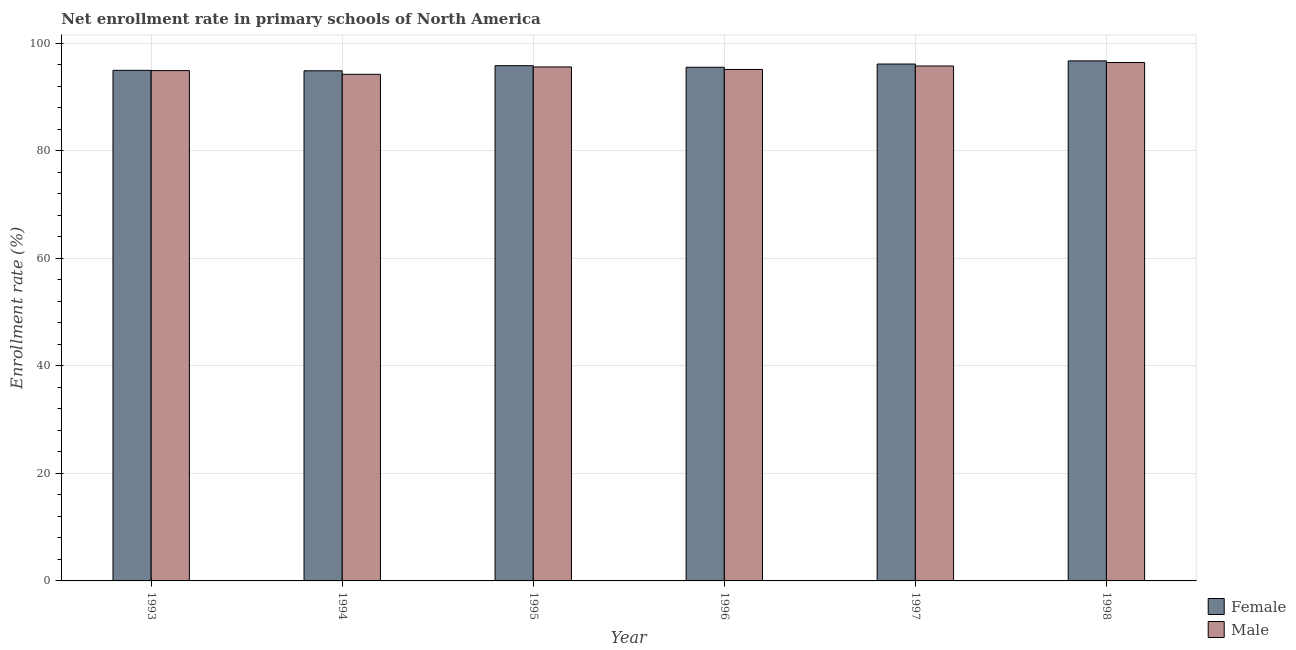Are the number of bars per tick equal to the number of legend labels?
Keep it short and to the point. Yes. How many bars are there on the 1st tick from the left?
Your answer should be compact. 2. What is the enrollment rate of female students in 1997?
Keep it short and to the point. 96.17. Across all years, what is the maximum enrollment rate of female students?
Your answer should be compact. 96.76. Across all years, what is the minimum enrollment rate of male students?
Offer a very short reply. 94.26. In which year was the enrollment rate of female students minimum?
Give a very brief answer. 1994. What is the total enrollment rate of female students in the graph?
Your answer should be very brief. 574.28. What is the difference between the enrollment rate of male students in 1995 and that in 1997?
Offer a very short reply. -0.18. What is the difference between the enrollment rate of female students in 1997 and the enrollment rate of male students in 1996?
Offer a terse response. 0.6. What is the average enrollment rate of male students per year?
Offer a terse response. 95.38. In how many years, is the enrollment rate of female students greater than 60 %?
Offer a terse response. 6. What is the ratio of the enrollment rate of male students in 1995 to that in 1998?
Provide a short and direct response. 0.99. Is the difference between the enrollment rate of male students in 1993 and 1997 greater than the difference between the enrollment rate of female students in 1993 and 1997?
Your response must be concise. No. What is the difference between the highest and the second highest enrollment rate of female students?
Offer a terse response. 0.58. What is the difference between the highest and the lowest enrollment rate of male students?
Your answer should be compact. 2.19. What does the 2nd bar from the left in 1997 represents?
Your answer should be compact. Male. What does the 1st bar from the right in 1995 represents?
Your response must be concise. Male. Are all the bars in the graph horizontal?
Make the answer very short. No. How many years are there in the graph?
Your answer should be compact. 6. What is the difference between two consecutive major ticks on the Y-axis?
Offer a very short reply. 20. Does the graph contain any zero values?
Your answer should be compact. No. What is the title of the graph?
Make the answer very short. Net enrollment rate in primary schools of North America. What is the label or title of the X-axis?
Ensure brevity in your answer.  Year. What is the label or title of the Y-axis?
Your response must be concise. Enrollment rate (%). What is the Enrollment rate (%) of Female in 1993?
Your answer should be very brief. 95. What is the Enrollment rate (%) in Male in 1993?
Your response must be concise. 94.95. What is the Enrollment rate (%) of Female in 1994?
Give a very brief answer. 94.91. What is the Enrollment rate (%) of Male in 1994?
Your answer should be very brief. 94.26. What is the Enrollment rate (%) of Female in 1995?
Offer a terse response. 95.87. What is the Enrollment rate (%) of Male in 1995?
Your response must be concise. 95.63. What is the Enrollment rate (%) of Female in 1996?
Make the answer very short. 95.57. What is the Enrollment rate (%) in Male in 1996?
Your answer should be very brief. 95.16. What is the Enrollment rate (%) in Female in 1997?
Ensure brevity in your answer.  96.17. What is the Enrollment rate (%) in Male in 1997?
Offer a very short reply. 95.81. What is the Enrollment rate (%) of Female in 1998?
Offer a very short reply. 96.76. What is the Enrollment rate (%) of Male in 1998?
Provide a succinct answer. 96.45. Across all years, what is the maximum Enrollment rate (%) in Female?
Give a very brief answer. 96.76. Across all years, what is the maximum Enrollment rate (%) of Male?
Your answer should be very brief. 96.45. Across all years, what is the minimum Enrollment rate (%) in Female?
Ensure brevity in your answer.  94.91. Across all years, what is the minimum Enrollment rate (%) in Male?
Your answer should be compact. 94.26. What is the total Enrollment rate (%) in Female in the graph?
Offer a terse response. 574.28. What is the total Enrollment rate (%) in Male in the graph?
Ensure brevity in your answer.  572.26. What is the difference between the Enrollment rate (%) of Female in 1993 and that in 1994?
Provide a succinct answer. 0.08. What is the difference between the Enrollment rate (%) in Male in 1993 and that in 1994?
Your answer should be compact. 0.69. What is the difference between the Enrollment rate (%) in Female in 1993 and that in 1995?
Your response must be concise. -0.87. What is the difference between the Enrollment rate (%) of Male in 1993 and that in 1995?
Provide a short and direct response. -0.68. What is the difference between the Enrollment rate (%) of Female in 1993 and that in 1996?
Provide a succinct answer. -0.57. What is the difference between the Enrollment rate (%) of Male in 1993 and that in 1996?
Ensure brevity in your answer.  -0.22. What is the difference between the Enrollment rate (%) in Female in 1993 and that in 1997?
Provide a succinct answer. -1.18. What is the difference between the Enrollment rate (%) in Male in 1993 and that in 1997?
Your response must be concise. -0.86. What is the difference between the Enrollment rate (%) of Female in 1993 and that in 1998?
Give a very brief answer. -1.76. What is the difference between the Enrollment rate (%) of Male in 1993 and that in 1998?
Offer a terse response. -1.5. What is the difference between the Enrollment rate (%) in Female in 1994 and that in 1995?
Make the answer very short. -0.95. What is the difference between the Enrollment rate (%) in Male in 1994 and that in 1995?
Your answer should be very brief. -1.37. What is the difference between the Enrollment rate (%) of Female in 1994 and that in 1996?
Make the answer very short. -0.66. What is the difference between the Enrollment rate (%) of Male in 1994 and that in 1996?
Your answer should be very brief. -0.9. What is the difference between the Enrollment rate (%) in Female in 1994 and that in 1997?
Provide a succinct answer. -1.26. What is the difference between the Enrollment rate (%) in Male in 1994 and that in 1997?
Ensure brevity in your answer.  -1.55. What is the difference between the Enrollment rate (%) in Female in 1994 and that in 1998?
Your answer should be very brief. -1.84. What is the difference between the Enrollment rate (%) in Male in 1994 and that in 1998?
Give a very brief answer. -2.19. What is the difference between the Enrollment rate (%) of Female in 1995 and that in 1996?
Keep it short and to the point. 0.29. What is the difference between the Enrollment rate (%) in Male in 1995 and that in 1996?
Offer a terse response. 0.46. What is the difference between the Enrollment rate (%) in Female in 1995 and that in 1997?
Your answer should be very brief. -0.31. What is the difference between the Enrollment rate (%) of Male in 1995 and that in 1997?
Keep it short and to the point. -0.18. What is the difference between the Enrollment rate (%) of Female in 1995 and that in 1998?
Your answer should be very brief. -0.89. What is the difference between the Enrollment rate (%) of Male in 1995 and that in 1998?
Ensure brevity in your answer.  -0.82. What is the difference between the Enrollment rate (%) in Female in 1996 and that in 1997?
Make the answer very short. -0.6. What is the difference between the Enrollment rate (%) in Male in 1996 and that in 1997?
Make the answer very short. -0.64. What is the difference between the Enrollment rate (%) of Female in 1996 and that in 1998?
Make the answer very short. -1.19. What is the difference between the Enrollment rate (%) in Male in 1996 and that in 1998?
Give a very brief answer. -1.29. What is the difference between the Enrollment rate (%) of Female in 1997 and that in 1998?
Offer a very short reply. -0.58. What is the difference between the Enrollment rate (%) in Male in 1997 and that in 1998?
Provide a short and direct response. -0.64. What is the difference between the Enrollment rate (%) in Female in 1993 and the Enrollment rate (%) in Male in 1994?
Your answer should be compact. 0.74. What is the difference between the Enrollment rate (%) in Female in 1993 and the Enrollment rate (%) in Male in 1995?
Keep it short and to the point. -0.63. What is the difference between the Enrollment rate (%) in Female in 1993 and the Enrollment rate (%) in Male in 1996?
Your answer should be very brief. -0.17. What is the difference between the Enrollment rate (%) of Female in 1993 and the Enrollment rate (%) of Male in 1997?
Your answer should be very brief. -0.81. What is the difference between the Enrollment rate (%) of Female in 1993 and the Enrollment rate (%) of Male in 1998?
Offer a very short reply. -1.45. What is the difference between the Enrollment rate (%) in Female in 1994 and the Enrollment rate (%) in Male in 1995?
Give a very brief answer. -0.71. What is the difference between the Enrollment rate (%) of Female in 1994 and the Enrollment rate (%) of Male in 1996?
Provide a short and direct response. -0.25. What is the difference between the Enrollment rate (%) of Female in 1994 and the Enrollment rate (%) of Male in 1997?
Keep it short and to the point. -0.89. What is the difference between the Enrollment rate (%) in Female in 1994 and the Enrollment rate (%) in Male in 1998?
Offer a terse response. -1.54. What is the difference between the Enrollment rate (%) of Female in 1995 and the Enrollment rate (%) of Male in 1996?
Offer a very short reply. 0.7. What is the difference between the Enrollment rate (%) of Female in 1995 and the Enrollment rate (%) of Male in 1997?
Offer a very short reply. 0.06. What is the difference between the Enrollment rate (%) in Female in 1995 and the Enrollment rate (%) in Male in 1998?
Ensure brevity in your answer.  -0.58. What is the difference between the Enrollment rate (%) of Female in 1996 and the Enrollment rate (%) of Male in 1997?
Your answer should be compact. -0.24. What is the difference between the Enrollment rate (%) of Female in 1996 and the Enrollment rate (%) of Male in 1998?
Your answer should be compact. -0.88. What is the difference between the Enrollment rate (%) of Female in 1997 and the Enrollment rate (%) of Male in 1998?
Your response must be concise. -0.28. What is the average Enrollment rate (%) in Female per year?
Your answer should be compact. 95.71. What is the average Enrollment rate (%) of Male per year?
Offer a very short reply. 95.38. In the year 1993, what is the difference between the Enrollment rate (%) of Female and Enrollment rate (%) of Male?
Your response must be concise. 0.05. In the year 1994, what is the difference between the Enrollment rate (%) in Female and Enrollment rate (%) in Male?
Your answer should be compact. 0.65. In the year 1995, what is the difference between the Enrollment rate (%) of Female and Enrollment rate (%) of Male?
Make the answer very short. 0.24. In the year 1996, what is the difference between the Enrollment rate (%) in Female and Enrollment rate (%) in Male?
Your response must be concise. 0.41. In the year 1997, what is the difference between the Enrollment rate (%) of Female and Enrollment rate (%) of Male?
Your response must be concise. 0.37. In the year 1998, what is the difference between the Enrollment rate (%) of Female and Enrollment rate (%) of Male?
Offer a very short reply. 0.31. What is the ratio of the Enrollment rate (%) in Male in 1993 to that in 1994?
Keep it short and to the point. 1.01. What is the ratio of the Enrollment rate (%) in Female in 1993 to that in 1995?
Provide a short and direct response. 0.99. What is the ratio of the Enrollment rate (%) in Female in 1993 to that in 1997?
Your answer should be compact. 0.99. What is the ratio of the Enrollment rate (%) in Male in 1993 to that in 1997?
Ensure brevity in your answer.  0.99. What is the ratio of the Enrollment rate (%) of Female in 1993 to that in 1998?
Your answer should be compact. 0.98. What is the ratio of the Enrollment rate (%) in Male in 1993 to that in 1998?
Give a very brief answer. 0.98. What is the ratio of the Enrollment rate (%) of Male in 1994 to that in 1995?
Offer a very short reply. 0.99. What is the ratio of the Enrollment rate (%) of Female in 1994 to that in 1996?
Provide a short and direct response. 0.99. What is the ratio of the Enrollment rate (%) in Female in 1994 to that in 1997?
Provide a short and direct response. 0.99. What is the ratio of the Enrollment rate (%) of Male in 1994 to that in 1997?
Give a very brief answer. 0.98. What is the ratio of the Enrollment rate (%) in Female in 1994 to that in 1998?
Your response must be concise. 0.98. What is the ratio of the Enrollment rate (%) of Male in 1994 to that in 1998?
Ensure brevity in your answer.  0.98. What is the ratio of the Enrollment rate (%) in Male in 1995 to that in 1996?
Your answer should be compact. 1. What is the ratio of the Enrollment rate (%) in Male in 1995 to that in 1997?
Give a very brief answer. 1. What is the ratio of the Enrollment rate (%) in Male in 1995 to that in 1998?
Offer a terse response. 0.99. What is the ratio of the Enrollment rate (%) in Male in 1996 to that in 1998?
Give a very brief answer. 0.99. What is the ratio of the Enrollment rate (%) of Female in 1997 to that in 1998?
Provide a succinct answer. 0.99. What is the ratio of the Enrollment rate (%) in Male in 1997 to that in 1998?
Ensure brevity in your answer.  0.99. What is the difference between the highest and the second highest Enrollment rate (%) in Female?
Your answer should be compact. 0.58. What is the difference between the highest and the second highest Enrollment rate (%) in Male?
Make the answer very short. 0.64. What is the difference between the highest and the lowest Enrollment rate (%) of Female?
Provide a succinct answer. 1.84. What is the difference between the highest and the lowest Enrollment rate (%) of Male?
Offer a very short reply. 2.19. 